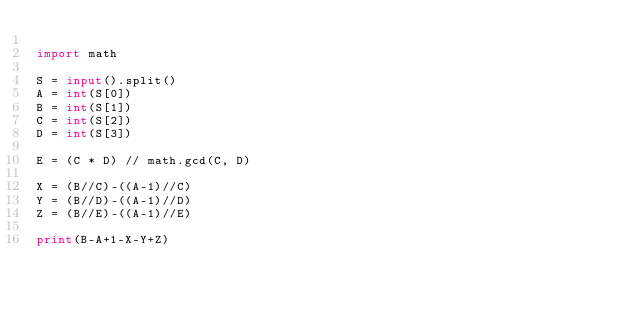Convert code to text. <code><loc_0><loc_0><loc_500><loc_500><_Python_>
import math

S = input().split()
A = int(S[0])
B = int(S[1])
C = int(S[2])
D = int(S[3])

E = (C * D) // math.gcd(C, D)

X = (B//C)-((A-1)//C)
Y = (B//D)-((A-1)//D)
Z = (B//E)-((A-1)//E)

print(B-A+1-X-Y+Z)

</code> 